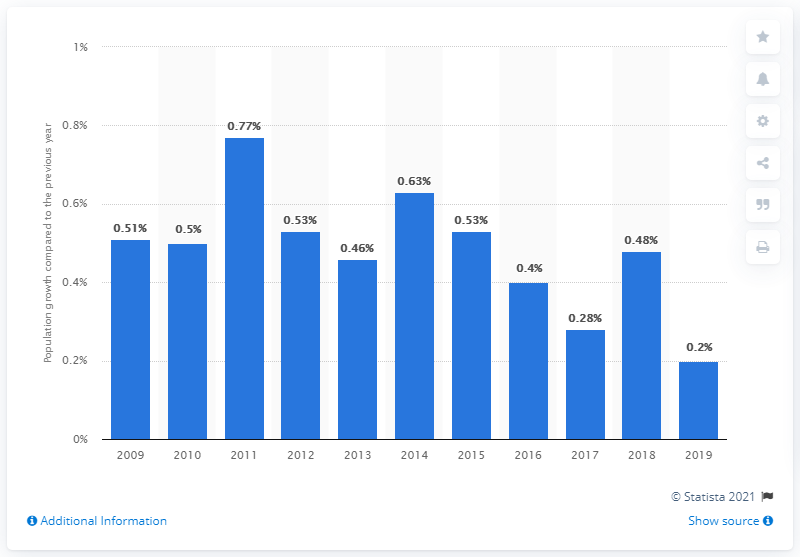Highlight a few significant elements in this photo. South Korea's population increased by 0.2% in 2019. 